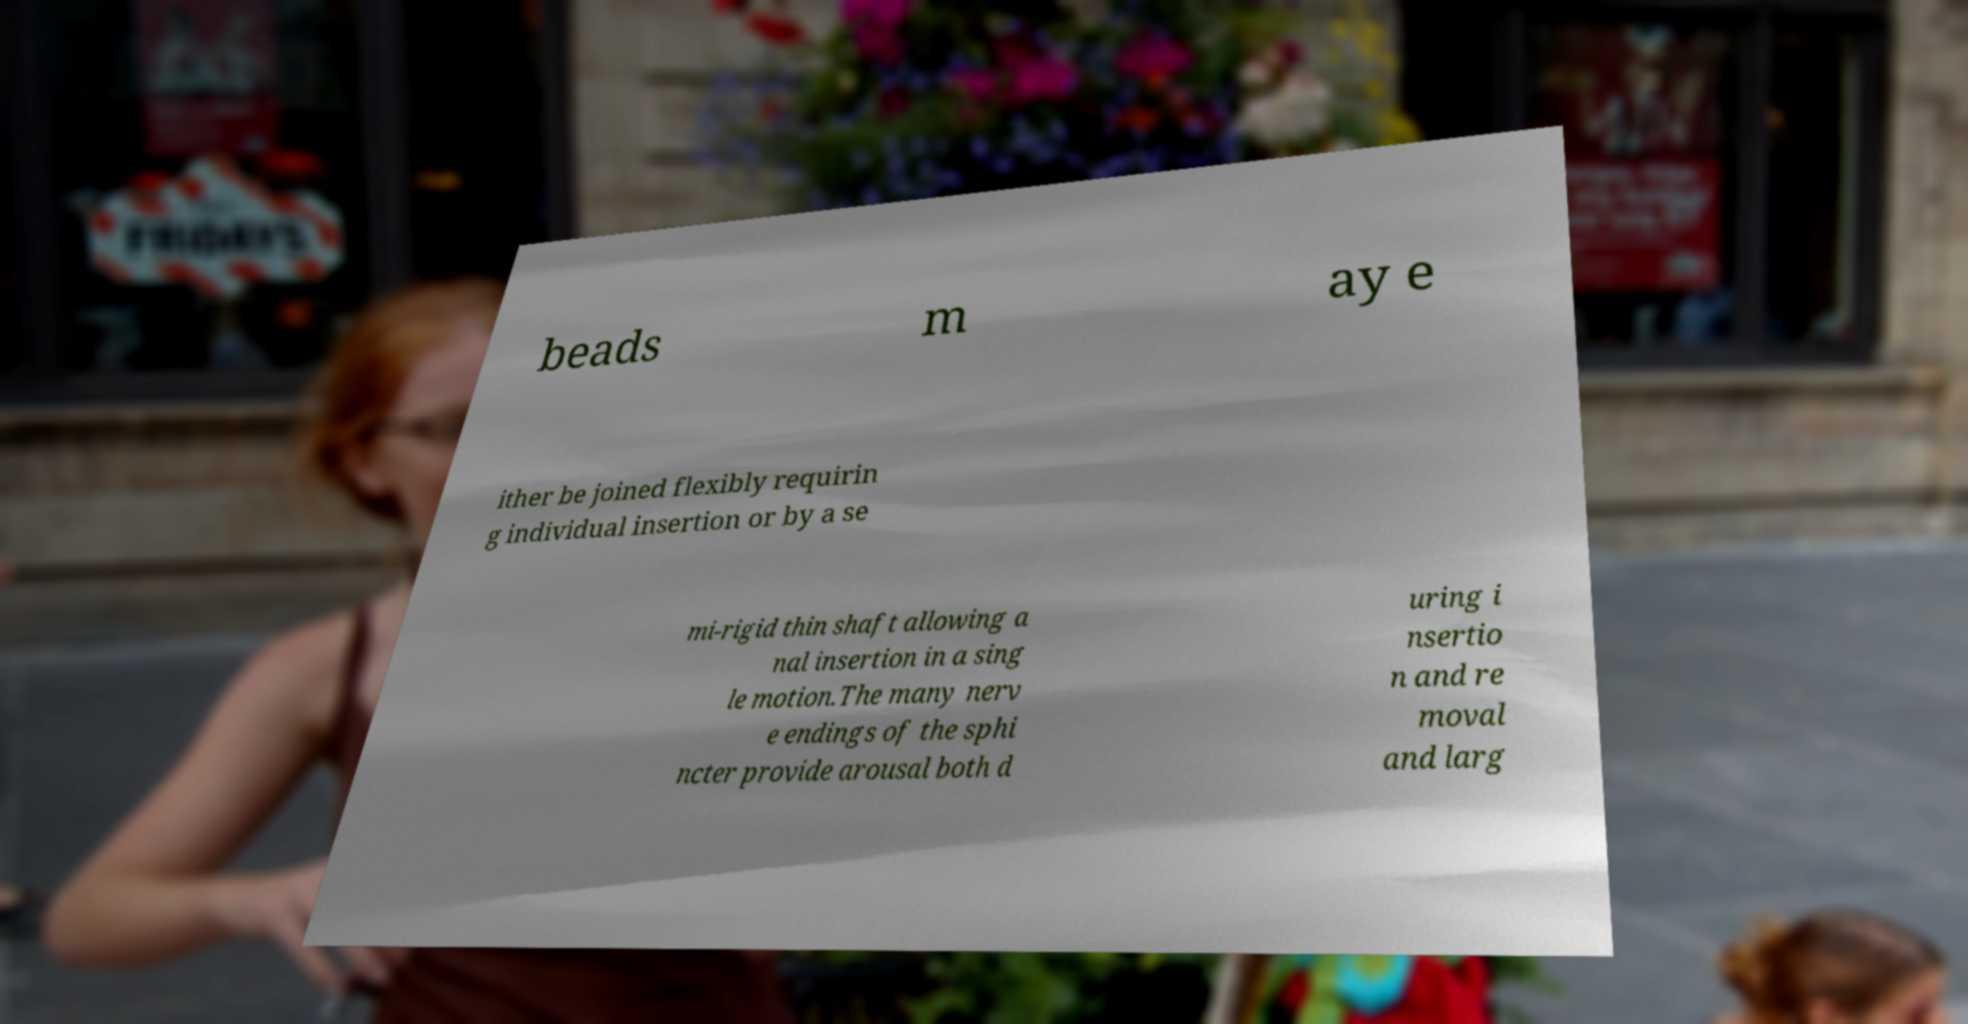What messages or text are displayed in this image? I need them in a readable, typed format. beads m ay e ither be joined flexibly requirin g individual insertion or by a se mi-rigid thin shaft allowing a nal insertion in a sing le motion.The many nerv e endings of the sphi ncter provide arousal both d uring i nsertio n and re moval and larg 